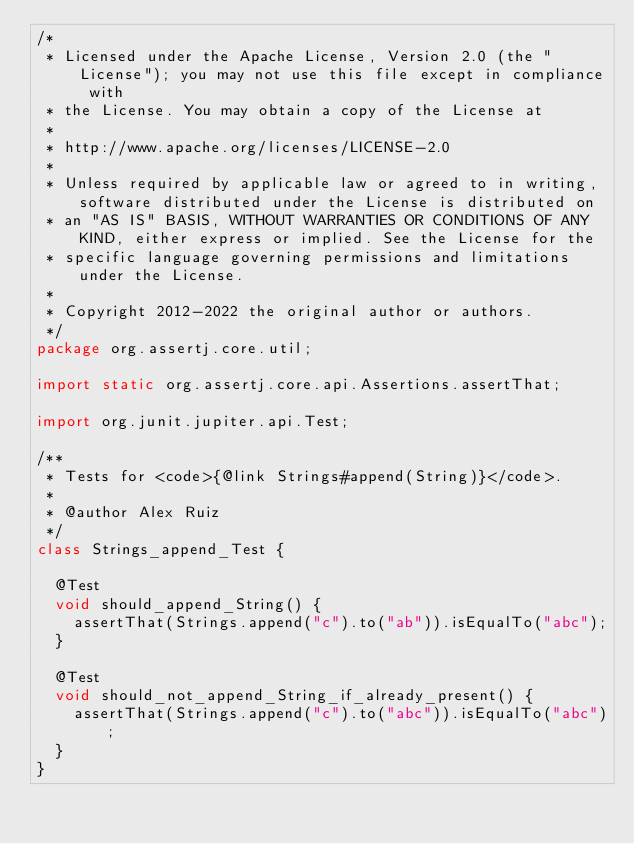Convert code to text. <code><loc_0><loc_0><loc_500><loc_500><_Java_>/*
 * Licensed under the Apache License, Version 2.0 (the "License"); you may not use this file except in compliance with
 * the License. You may obtain a copy of the License at
 *
 * http://www.apache.org/licenses/LICENSE-2.0
 *
 * Unless required by applicable law or agreed to in writing, software distributed under the License is distributed on
 * an "AS IS" BASIS, WITHOUT WARRANTIES OR CONDITIONS OF ANY KIND, either express or implied. See the License for the
 * specific language governing permissions and limitations under the License.
 *
 * Copyright 2012-2022 the original author or authors.
 */
package org.assertj.core.util;

import static org.assertj.core.api.Assertions.assertThat;

import org.junit.jupiter.api.Test;

/**
 * Tests for <code>{@link Strings#append(String)}</code>.
 * 
 * @author Alex Ruiz
 */
class Strings_append_Test {

  @Test
  void should_append_String() {
    assertThat(Strings.append("c").to("ab")).isEqualTo("abc");
  }

  @Test
  void should_not_append_String_if_already_present() {
    assertThat(Strings.append("c").to("abc")).isEqualTo("abc");
  }
}
</code> 